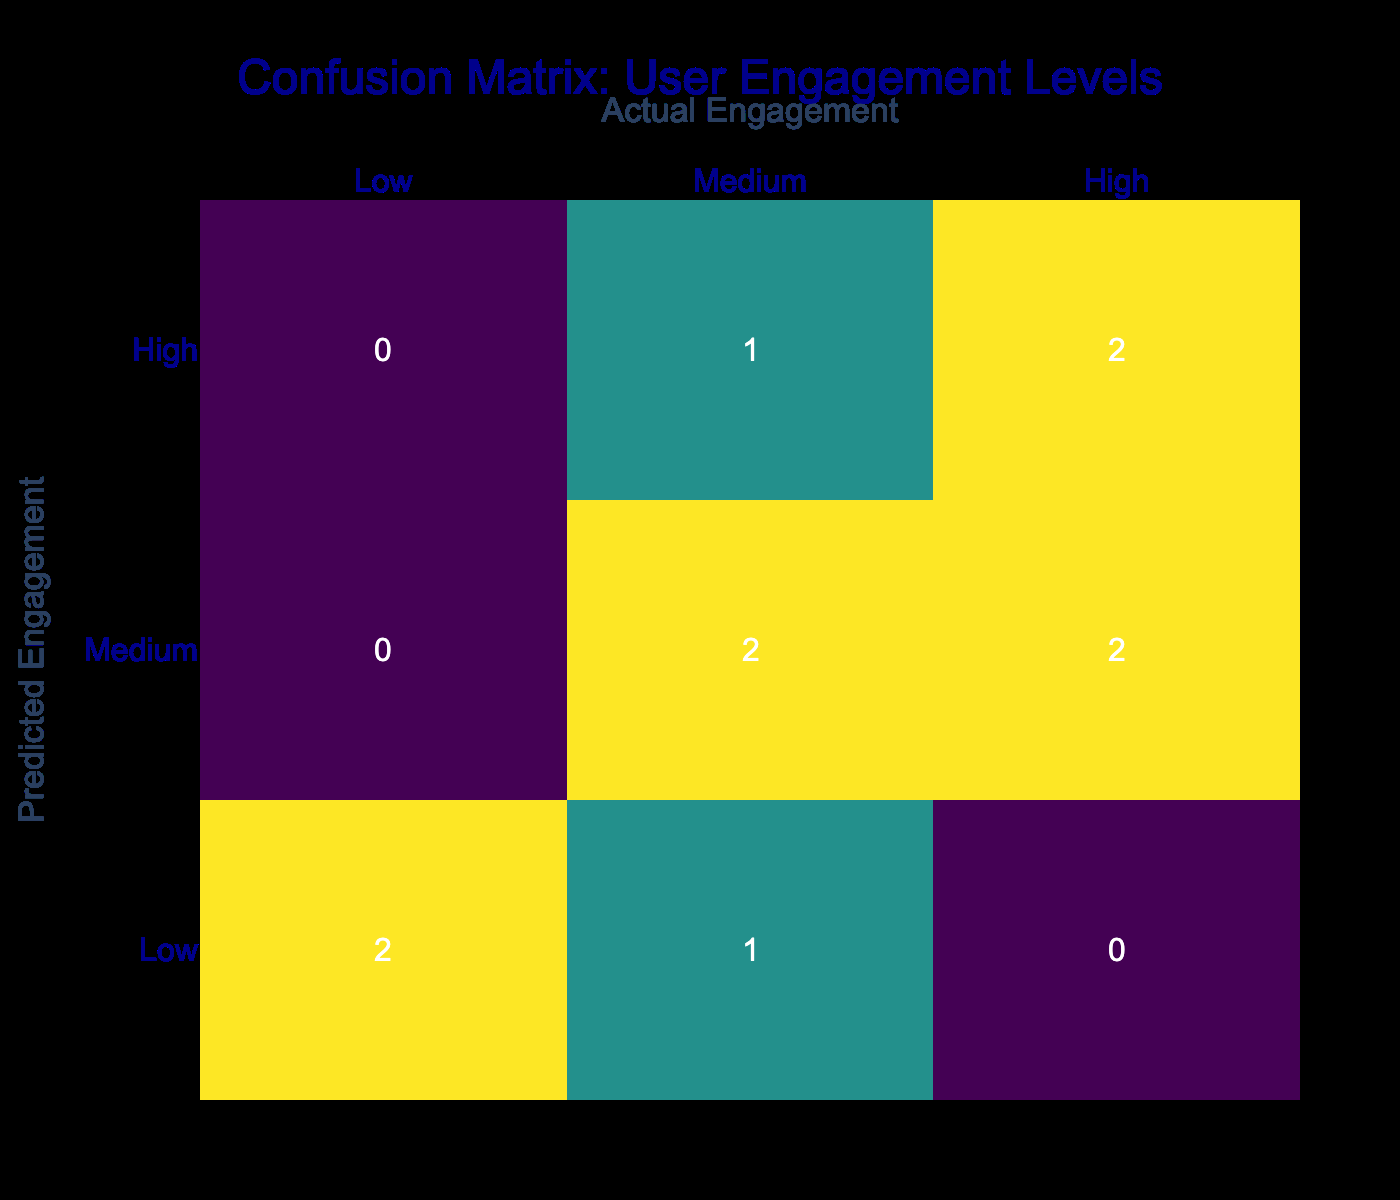What is the highest predicted engagement level in the confusion matrix? The highest predicted engagement level visible in the table is "High" since it appears as a row in the prediction categories.
Answer: High How many interactive displays were predicted to have medium engagement? By counting the number of occurrences in the "Medium" row of predicted engagement in the table, we find that "Medium" appears three times, corresponding to three displays.
Answer: 3 Is it true that all displays predicted to have high engagement also had high actual engagement? By checking the table, both "Apple II Interactive" and "IBM PC History" predicted to have high engagement show high actual engagement, confirming this statement is true.
Answer: Yes What is the total number of displays that were actually engaged at a low level? Looking at the "Low" column in actual engagement, there are two displays: "TRS-80 Exploration" and "Nextcube Innovation", summing to a total of 2 displays.
Answer: 2 How does the count of displays with medium actual engagement compare with those with high actual engagement? By examining the table, we see that there are three displays with medium actual engagement ("Commodore 64 Showcase", "ZX Spectrum Zone", "Tandy 1000 Trial") and two with high actual engagement ("Apple II Interactive", "IBM PC History"). Therefore, medium actual engagement displays outnumber high actual engagement displays by one.
Answer: Medium engagement displays outnumber high engagement displays by 1 What percentages of the displays predicted to have low engagement were actually engaged at a low level? There are two displays predicted to have low engagement ("Atari 2600 Experience" and "Nextcube Innovation"), and both were actually low. Thus, we calculate the percentage as (2/2) * 100 = 100%.
Answer: 100% Which user engagement level had the lowest predicted count? Checking the counts across the predicted engagement levels, the "High" predicted engagement level has the least count of occurrences among predictions with only four displays (2 high, 2 medium).
Answer: High How many displays had a mismatch between predicted and actual engagement levels? To find the mismatches, we check each display in the table; the mismatches occurred for 3 displays: "Commodore 64 Showcase", "Amiga Demonstration", and "Macintosh Immersion". Hence, the total count of mismatches is 3.
Answer: 3 